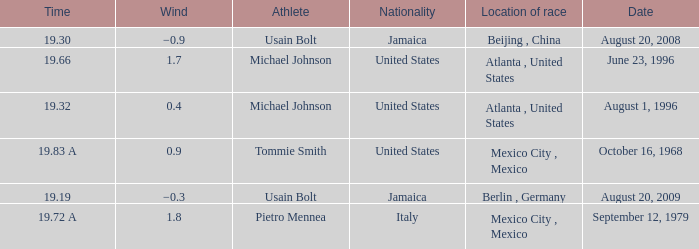What's the wind when the time was 19.32? 0.4. 